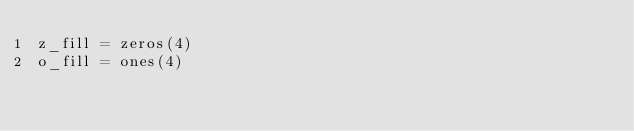<code> <loc_0><loc_0><loc_500><loc_500><_Matlab_>z_fill = zeros(4)
o_fill = ones(4)
</code> 